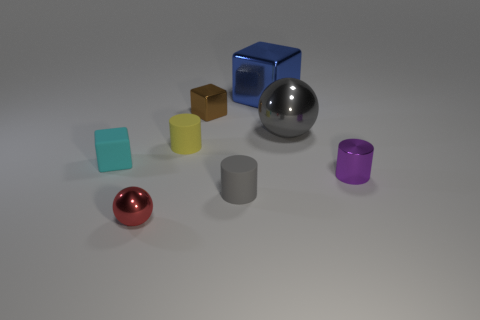What size is the blue cube?
Make the answer very short. Large. Is the number of large blue objects less than the number of matte cylinders?
Offer a very short reply. Yes. How many cylinders are the same color as the large metallic ball?
Give a very brief answer. 1. There is a tiny cylinder that is on the left side of the brown metallic cube; is it the same color as the large sphere?
Ensure brevity in your answer.  No. There is a small metallic object that is behind the purple metallic thing; what shape is it?
Offer a very short reply. Cube. Are there any big metallic balls to the left of the tiny rubber object right of the tiny yellow matte thing?
Your answer should be very brief. No. How many gray cylinders are made of the same material as the tiny red ball?
Make the answer very short. 0. There is a shiny block that is on the left side of the gray object that is left of the big gray thing in front of the blue block; what is its size?
Make the answer very short. Small. There is a brown shiny thing; what number of cubes are left of it?
Offer a terse response. 1. Are there more large purple shiny balls than balls?
Your answer should be very brief. No. 